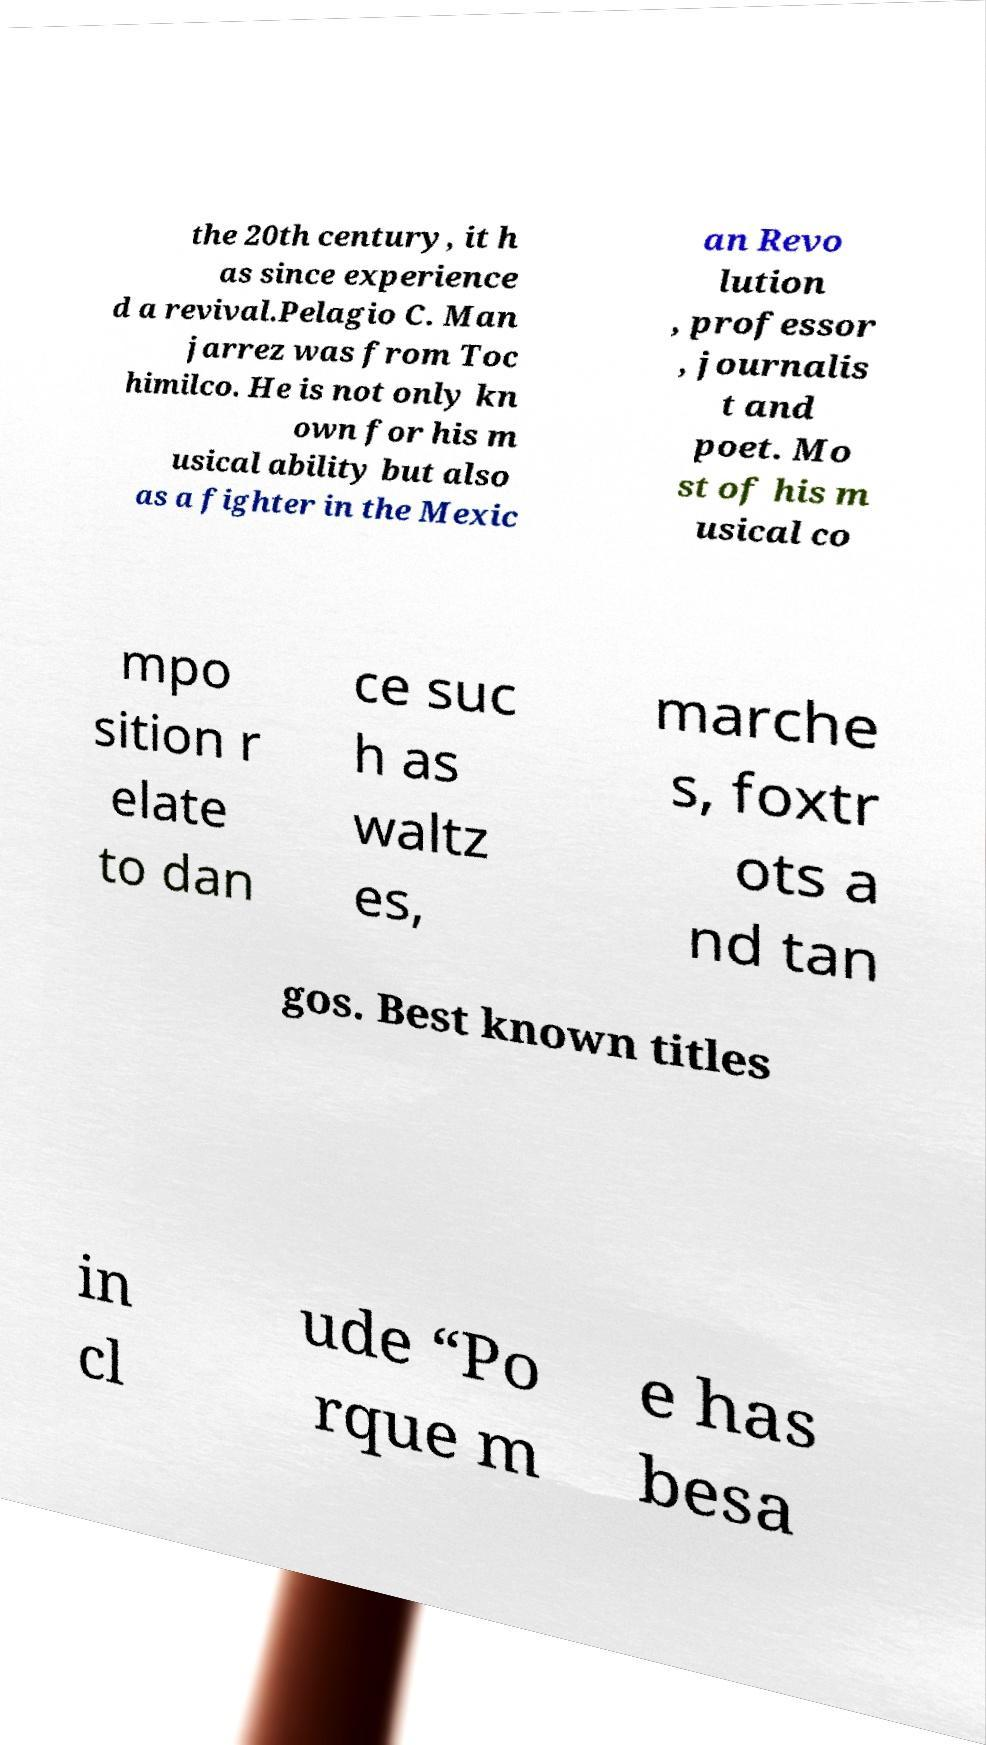What messages or text are displayed in this image? I need them in a readable, typed format. the 20th century, it h as since experience d a revival.Pelagio C. Man jarrez was from Toc himilco. He is not only kn own for his m usical ability but also as a fighter in the Mexic an Revo lution , professor , journalis t and poet. Mo st of his m usical co mpo sition r elate to dan ce suc h as waltz es, marche s, foxtr ots a nd tan gos. Best known titles in cl ude “Po rque m e has besa 